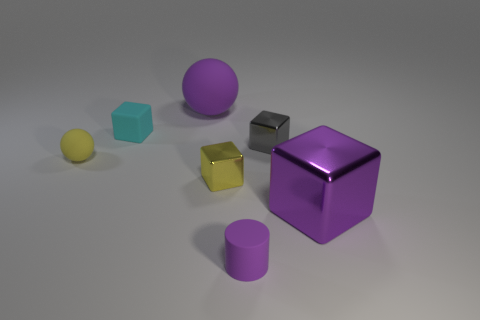What number of spheres are on the right side of the block on the left side of the large thing that is on the left side of the purple matte cylinder?
Your response must be concise. 1. What number of large shiny objects have the same shape as the small yellow rubber thing?
Your answer should be compact. 0. Does the block left of the purple matte ball have the same color as the large rubber ball?
Offer a terse response. No. The tiny metallic object that is in front of the matte sphere that is in front of the large thing on the left side of the small rubber cylinder is what shape?
Your answer should be very brief. Cube. Is the size of the yellow cube the same as the rubber object that is behind the cyan matte block?
Offer a very short reply. No. Are there any red metallic spheres that have the same size as the purple shiny cube?
Provide a succinct answer. No. What number of other objects are there of the same material as the small cylinder?
Your response must be concise. 3. What color is the block that is both in front of the gray metal object and to the left of the gray thing?
Make the answer very short. Yellow. Is the yellow object left of the tiny cyan object made of the same material as the object that is right of the tiny gray object?
Give a very brief answer. No. There is a purple thing that is in front of the purple shiny cube; is its size the same as the big purple block?
Offer a terse response. No. 